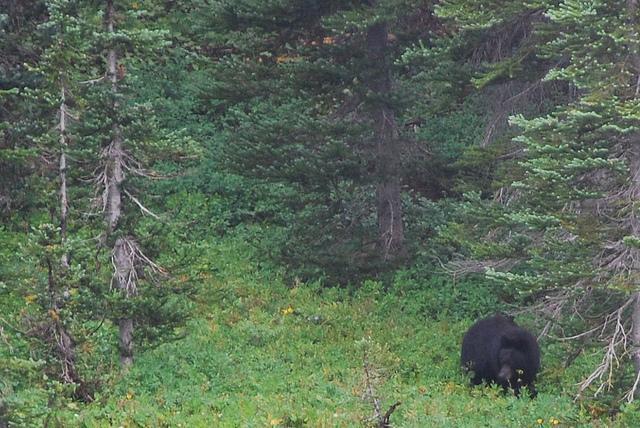How many bears are in this area?
Give a very brief answer. 1. 